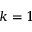Convert formula to latex. <formula><loc_0><loc_0><loc_500><loc_500>k = 1</formula> 